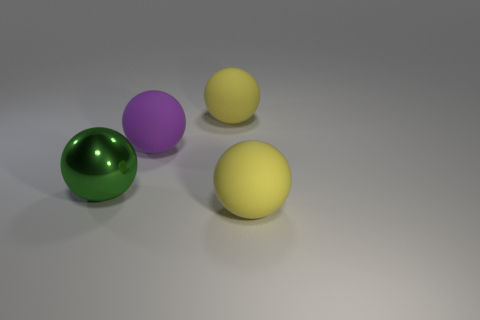Is the green sphere the same size as the purple sphere?
Ensure brevity in your answer.  Yes. There is a purple object that is the same size as the green metallic object; what is its shape?
Provide a short and direct response. Sphere. There is a ball in front of the metallic sphere; is it the same size as the big green sphere?
Your answer should be compact. Yes. What is the material of the purple object that is the same size as the green metal thing?
Your answer should be compact. Rubber. There is a big rubber object that is behind the purple object that is behind the green ball; is there a yellow rubber thing that is right of it?
Make the answer very short. Yes. Does the big sphere in front of the large green metal object have the same color as the big matte object behind the large purple object?
Provide a succinct answer. Yes. Is there a large cyan ball?
Your answer should be very brief. No. There is a yellow matte object that is in front of the big rubber ball that is behind the purple rubber object that is behind the large metal ball; what is its size?
Make the answer very short. Large. Is the shape of the purple object the same as the big matte thing in front of the metallic object?
Your response must be concise. Yes. What number of cubes are either red metallic objects or green objects?
Give a very brief answer. 0. 